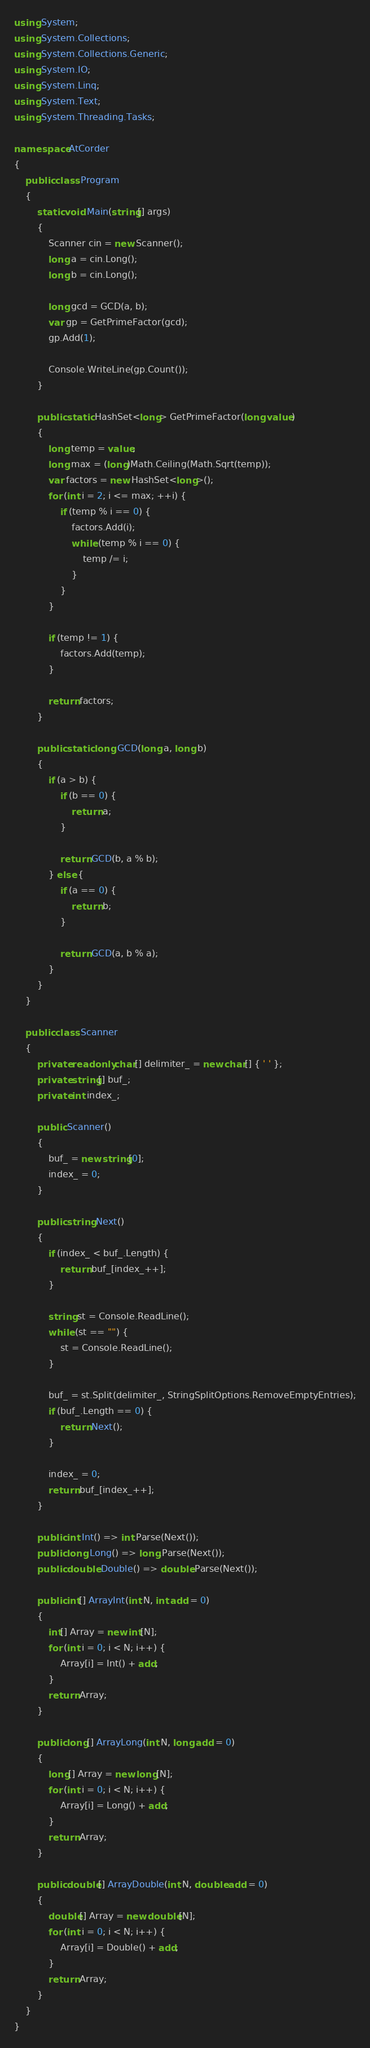<code> <loc_0><loc_0><loc_500><loc_500><_C#_>using System;
using System.Collections;
using System.Collections.Generic;
using System.IO;
using System.Linq;
using System.Text;
using System.Threading.Tasks;

namespace AtCorder
{
	public class Program
	{
		static void Main(string[] args)
		{
			Scanner cin = new Scanner();
			long a = cin.Long();
			long b = cin.Long();

			long gcd = GCD(a, b);
			var gp = GetPrimeFactor(gcd);
			gp.Add(1);

			Console.WriteLine(gp.Count());
		}

		public static HashSet<long> GetPrimeFactor(long value)
		{
			long temp = value;
			long max = (long)Math.Ceiling(Math.Sqrt(temp));
			var factors = new HashSet<long>();
			for (int i = 2; i <= max; ++i) {
				if (temp % i == 0) {
					factors.Add(i);
					while (temp % i == 0) {
						temp /= i;
					}
				}
			}

			if (temp != 1) {
				factors.Add(temp);
			}

			return factors;
		}

		public static long GCD(long a, long b)
		{
			if (a > b) {
				if (b == 0) {
					return a;
				}

				return GCD(b, a % b);
			} else {
				if (a == 0) {
					return b;
				}

				return GCD(a, b % a);
			}
		}
	}

	public class Scanner
	{
		private readonly char[] delimiter_ = new char[] { ' ' };
		private string[] buf_;
		private int index_;

		public Scanner()
		{
			buf_ = new string[0];
			index_ = 0;
		}

		public string Next()
		{
			if (index_ < buf_.Length) {
				return buf_[index_++];
			}

			string st = Console.ReadLine();
			while (st == "") {
				st = Console.ReadLine();
			}

			buf_ = st.Split(delimiter_, StringSplitOptions.RemoveEmptyEntries);
			if (buf_.Length == 0) {
				return Next();
			}

			index_ = 0;
			return buf_[index_++];
		}

		public int Int() => int.Parse(Next());
		public long Long() => long.Parse(Next());
		public double Double() => double.Parse(Next());

		public int[] ArrayInt(int N, int add = 0)
		{
			int[] Array = new int[N];
			for (int i = 0; i < N; i++) {
				Array[i] = Int() + add;
			}
			return Array;
		}

		public long[] ArrayLong(int N, long add = 0)
		{
			long[] Array = new long[N];
			for (int i = 0; i < N; i++) {
				Array[i] = Long() + add;
			}
			return Array;
		}

		public double[] ArrayDouble(int N, double add = 0)
		{
			double[] Array = new double[N];
			for (int i = 0; i < N; i++) {
				Array[i] = Double() + add;
			}
			return Array;
		}
	}
}</code> 